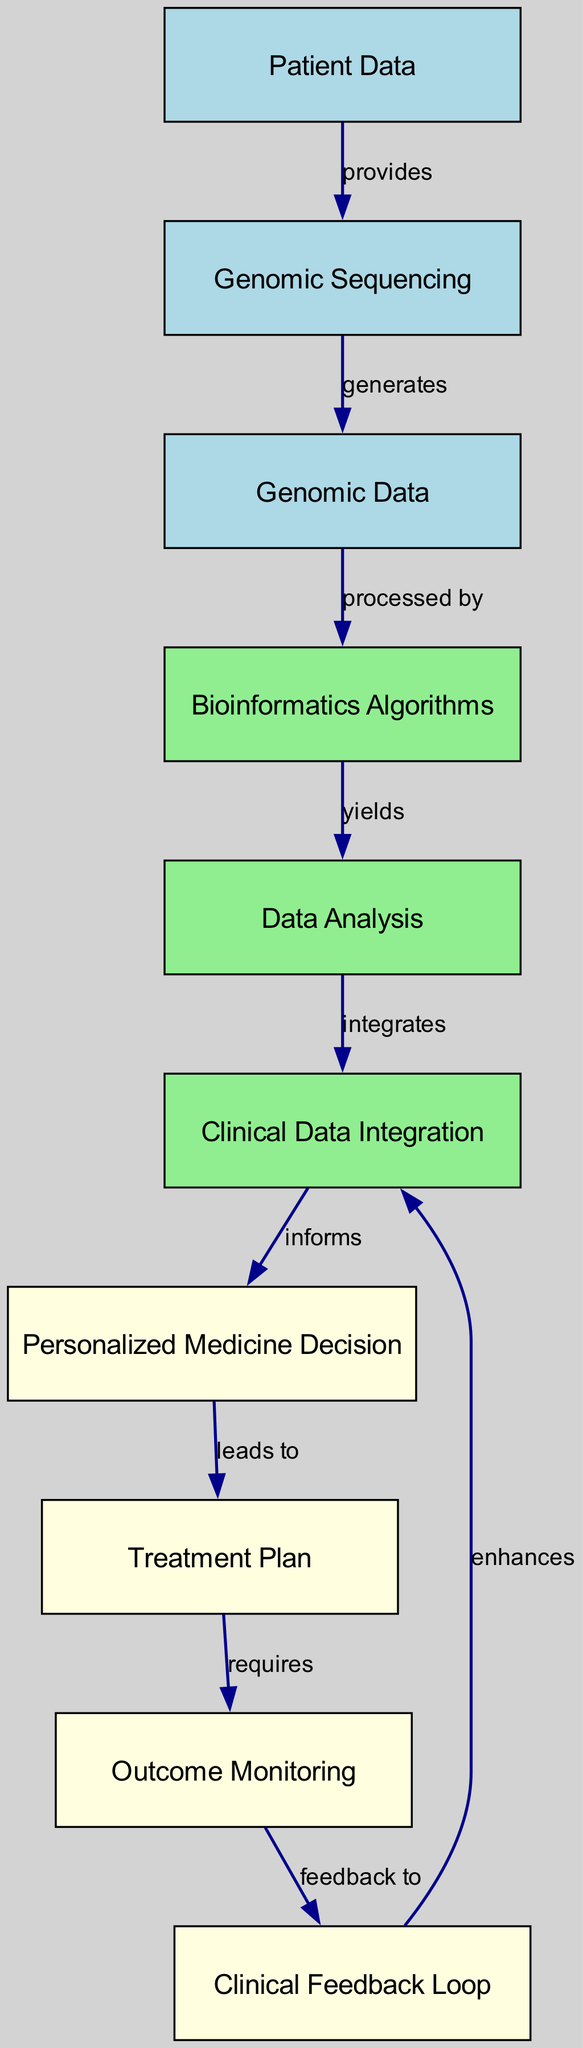What is the first node in the diagram? The first node is labeled "Patient Data," which is the initial input that provides information necessary for the subsequent processes in the diagram.
Answer: Patient Data How many nodes are in the diagram? The diagram contains a total of ten nodes, which represent various elements in the personalized medicine decision system.
Answer: Ten What relationship exists between "Genomic Data" and "Bioinformatics Algorithms"? "Genomic Data" is processed by "Bioinformatics Algorithms," indicating that the genomic information is analyzed through algorithms to extract meaningful insights.
Answer: Processed by What does the "Personalized Medicine Decision" lead to? The "Personalized Medicine Decision" leads to the "Treatment Plan," suggesting that the decision-making process results in a tailored treatment strategy for the patient.
Answer: Treatment Plan What enhances "Clinical Data Integration"? The "Clinical Feedback Loop" enhances "Clinical Data Integration," meaning that feedback from the clinical outcomes further improves the integration of clinical data into the decision-making process.
Answer: Enhances How is "Outcome Monitoring" connected to the diagram? "Outcome Monitoring" requires a "Treatment Plan,” indicating that monitoring the results depends on the implementation of the treatment that was planned based on the personalized medicine decision.
Answer: Requires What two processes contribute to forming a "Personalized Medicine Decision"? The processes that contribute are "Data Analysis" and "Clinical Data Integration," showing that insights from data analysis and clinical data together inform the decision-making in personalized medicine.
Answer: Data Analysis and Clinical Data Integration What is generated by "Genomic Sequencing"? "Genomic Data" is generated by "Genomic Sequencing," indicating that the sequencing process provides the necessary genomic information for further analysis.
Answer: Genomic Data 